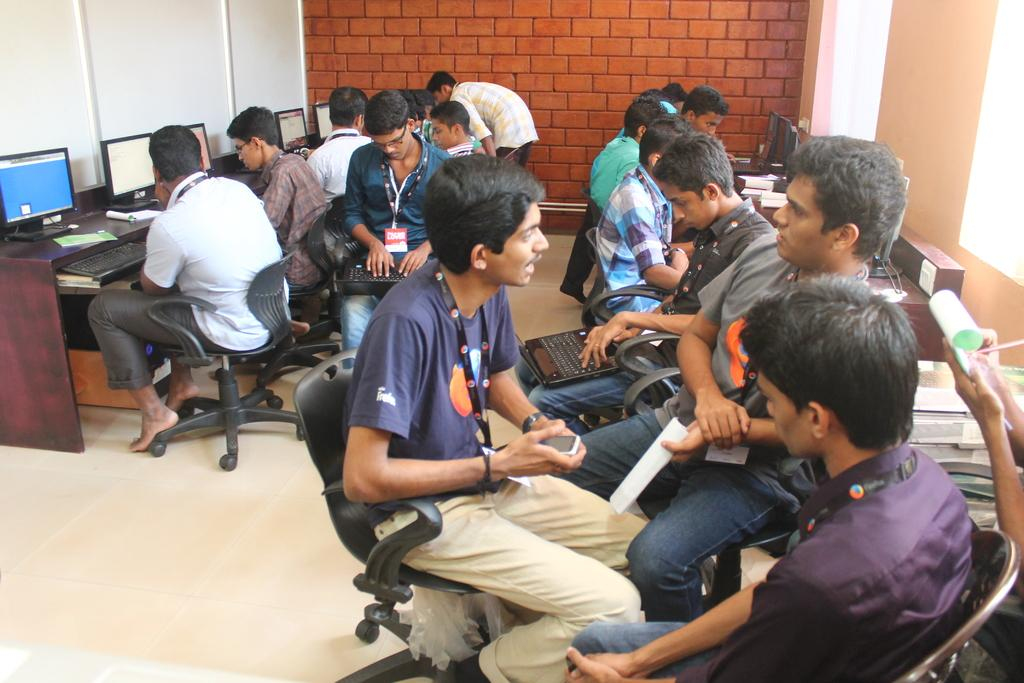What are the persons in the image doing? The persons in the image are sitting in chairs. What are two of the persons doing with the objects in front of them? Two of the persons are operating laptops. Where are the laptops located in relation to the persons? The laptops are in front of them. What color is the background wall in the image? The background wall is in brick color. What type of earth can be seen on the stage in the image? There is no stage or earth present in the image; it features persons sitting in chairs with laptops in front of them. 